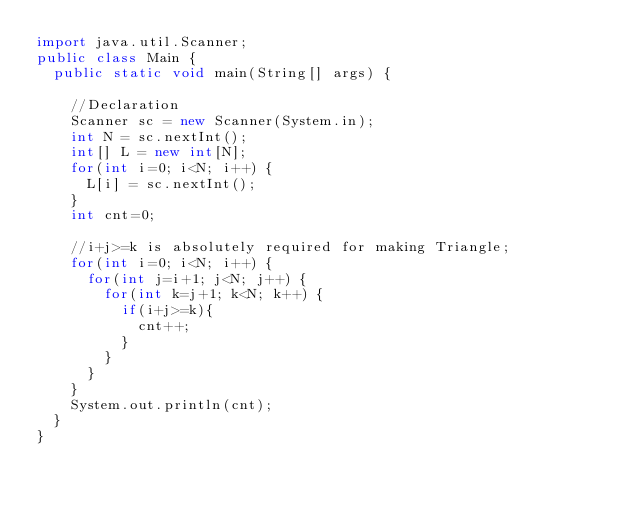Convert code to text. <code><loc_0><loc_0><loc_500><loc_500><_Java_>import java.util.Scanner;
public class Main {
  public static void main(String[] args) {
    
    //Declaration
    Scanner sc = new Scanner(System.in);
    int N = sc.nextInt();
    int[] L = new int[N];
    for(int i=0; i<N; i++) {
      L[i] = sc.nextInt();
    }
    int cnt=0;
    
    //i+j>=k is absolutely required for making Triangle;
    for(int i=0; i<N; i++) {
      for(int j=i+1; j<N; j++) {
        for(int k=j+1; k<N; k++) {
          if(i+j>=k){
            cnt++;
          }
        }
      }
    }
    System.out.println(cnt);
  }
}</code> 